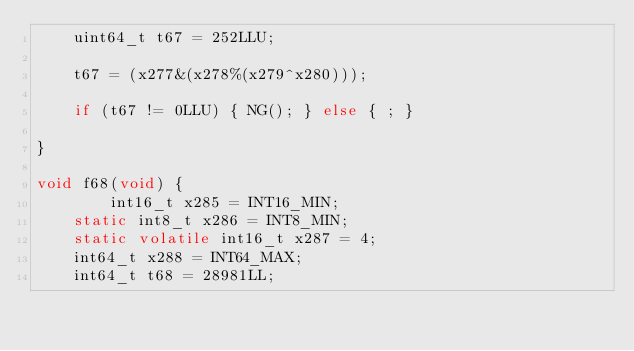<code> <loc_0><loc_0><loc_500><loc_500><_C_>	uint64_t t67 = 252LLU;

    t67 = (x277&(x278%(x279^x280)));

    if (t67 != 0LLU) { NG(); } else { ; }
	
}

void f68(void) {
    	int16_t x285 = INT16_MIN;
	static int8_t x286 = INT8_MIN;
	static volatile int16_t x287 = 4;
	int64_t x288 = INT64_MAX;
	int64_t t68 = 28981LL;
</code> 